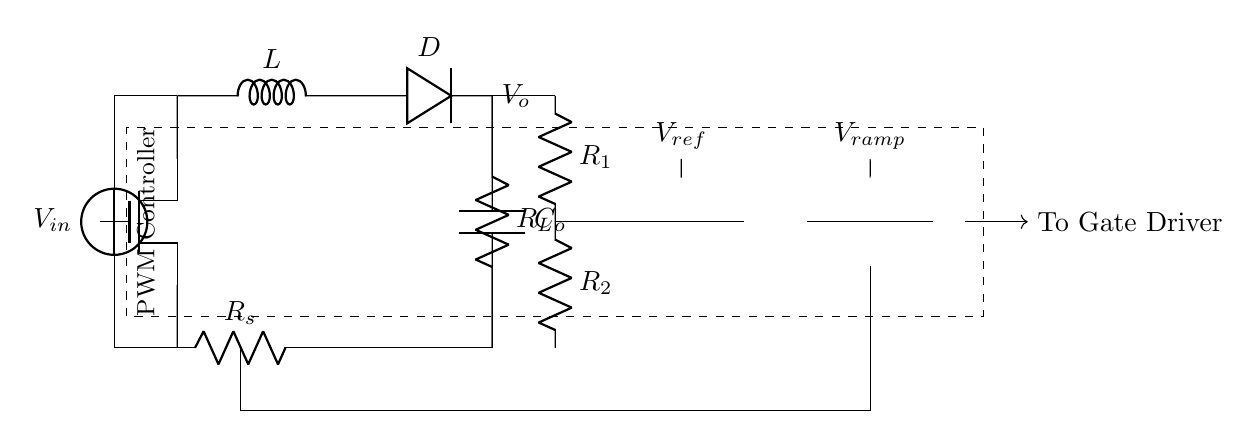What type of switch is used in this circuit? The switch used in this circuit is a MOSFET, indicated by the symbol labeled "mosfet" in the circuit.
Answer: MOSFET What is the purpose of the inductor in this circuit? The inductor stores energy when the MOSFET is on and releases it to the load when the MOSFET is off, which is crucial in a DC-DC converter for maintaining output voltage.
Answer: Energy storage What is the output voltage of the circuit? The output voltage is represented as V_o, which indicates the voltage that appears across the load R_L in the diagram.
Answer: V_o How does the feedback network influence the PWM controller? The feedback network consists of resistors that form a voltage divider, which helps compare the output voltage to a reference voltage, influencing the PWM controller to adjust duty cycle for stability.
Answer: Adjusts duty cycle What is the role of the current sense resistor in this circuit? The current sense resistor is used to measure the current flowing through the circuit by creating a small voltage drop proportional to the current, which is fed into the PWM comparator for current feedback control.
Answer: Current measurement What does the PWM comparator do in the circuit? The PWM comparator compares a ramp voltage to an error signal from the error amplifier, generating a PWM signal that controls the gate of the MOSFET to regulate the output voltage.
Answer: Generates PWM signal What is the significance of the reference voltage labeled V_ref? The reference voltage V_ref is used as a stable comparison level for the error amplifier to determine if the output voltage V_o is above or below the desired value, influencing the PWM signal accordingly.
Answer: Stability reference 